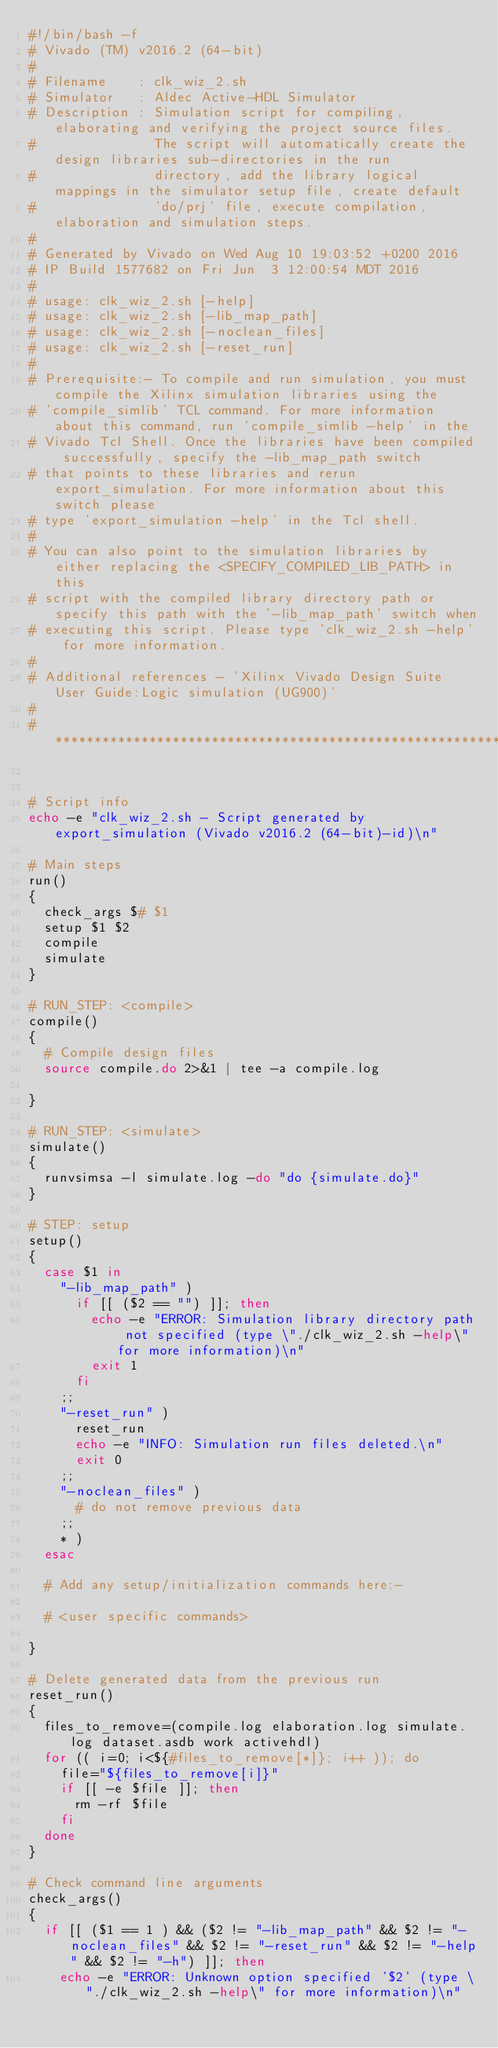<code> <loc_0><loc_0><loc_500><loc_500><_Bash_>#!/bin/bash -f
# Vivado (TM) v2016.2 (64-bit)
#
# Filename    : clk_wiz_2.sh
# Simulator   : Aldec Active-HDL Simulator
# Description : Simulation script for compiling, elaborating and verifying the project source files.
#               The script will automatically create the design libraries sub-directories in the run
#               directory, add the library logical mappings in the simulator setup file, create default
#               'do/prj' file, execute compilation, elaboration and simulation steps.
#
# Generated by Vivado on Wed Aug 10 19:03:52 +0200 2016
# IP Build 1577682 on Fri Jun  3 12:00:54 MDT 2016 
#
# usage: clk_wiz_2.sh [-help]
# usage: clk_wiz_2.sh [-lib_map_path]
# usage: clk_wiz_2.sh [-noclean_files]
# usage: clk_wiz_2.sh [-reset_run]
#
# Prerequisite:- To compile and run simulation, you must compile the Xilinx simulation libraries using the
# 'compile_simlib' TCL command. For more information about this command, run 'compile_simlib -help' in the
# Vivado Tcl Shell. Once the libraries have been compiled successfully, specify the -lib_map_path switch
# that points to these libraries and rerun export_simulation. For more information about this switch please
# type 'export_simulation -help' in the Tcl shell.
#
# You can also point to the simulation libraries by either replacing the <SPECIFY_COMPILED_LIB_PATH> in this
# script with the compiled library directory path or specify this path with the '-lib_map_path' switch when
# executing this script. Please type 'clk_wiz_2.sh -help' for more information.
#
# Additional references - 'Xilinx Vivado Design Suite User Guide:Logic simulation (UG900)'
#
# ********************************************************************************************************


# Script info
echo -e "clk_wiz_2.sh - Script generated by export_simulation (Vivado v2016.2 (64-bit)-id)\n"

# Main steps
run()
{
  check_args $# $1
  setup $1 $2
  compile
  simulate
}

# RUN_STEP: <compile>
compile()
{
  # Compile design files
  source compile.do 2>&1 | tee -a compile.log

}

# RUN_STEP: <simulate>
simulate()
{
  runvsimsa -l simulate.log -do "do {simulate.do}"
}

# STEP: setup
setup()
{
  case $1 in
    "-lib_map_path" )
      if [[ ($2 == "") ]]; then
        echo -e "ERROR: Simulation library directory path not specified (type \"./clk_wiz_2.sh -help\" for more information)\n"
        exit 1
      fi
    ;;
    "-reset_run" )
      reset_run
      echo -e "INFO: Simulation run files deleted.\n"
      exit 0
    ;;
    "-noclean_files" )
      # do not remove previous data
    ;;
    * )
  esac

  # Add any setup/initialization commands here:-

  # <user specific commands>

}

# Delete generated data from the previous run
reset_run()
{
  files_to_remove=(compile.log elaboration.log simulate.log dataset.asdb work activehdl)
  for (( i=0; i<${#files_to_remove[*]}; i++ )); do
    file="${files_to_remove[i]}"
    if [[ -e $file ]]; then
      rm -rf $file
    fi
  done
}

# Check command line arguments
check_args()
{
  if [[ ($1 == 1 ) && ($2 != "-lib_map_path" && $2 != "-noclean_files" && $2 != "-reset_run" && $2 != "-help" && $2 != "-h") ]]; then
    echo -e "ERROR: Unknown option specified '$2' (type \"./clk_wiz_2.sh -help\" for more information)\n"</code> 